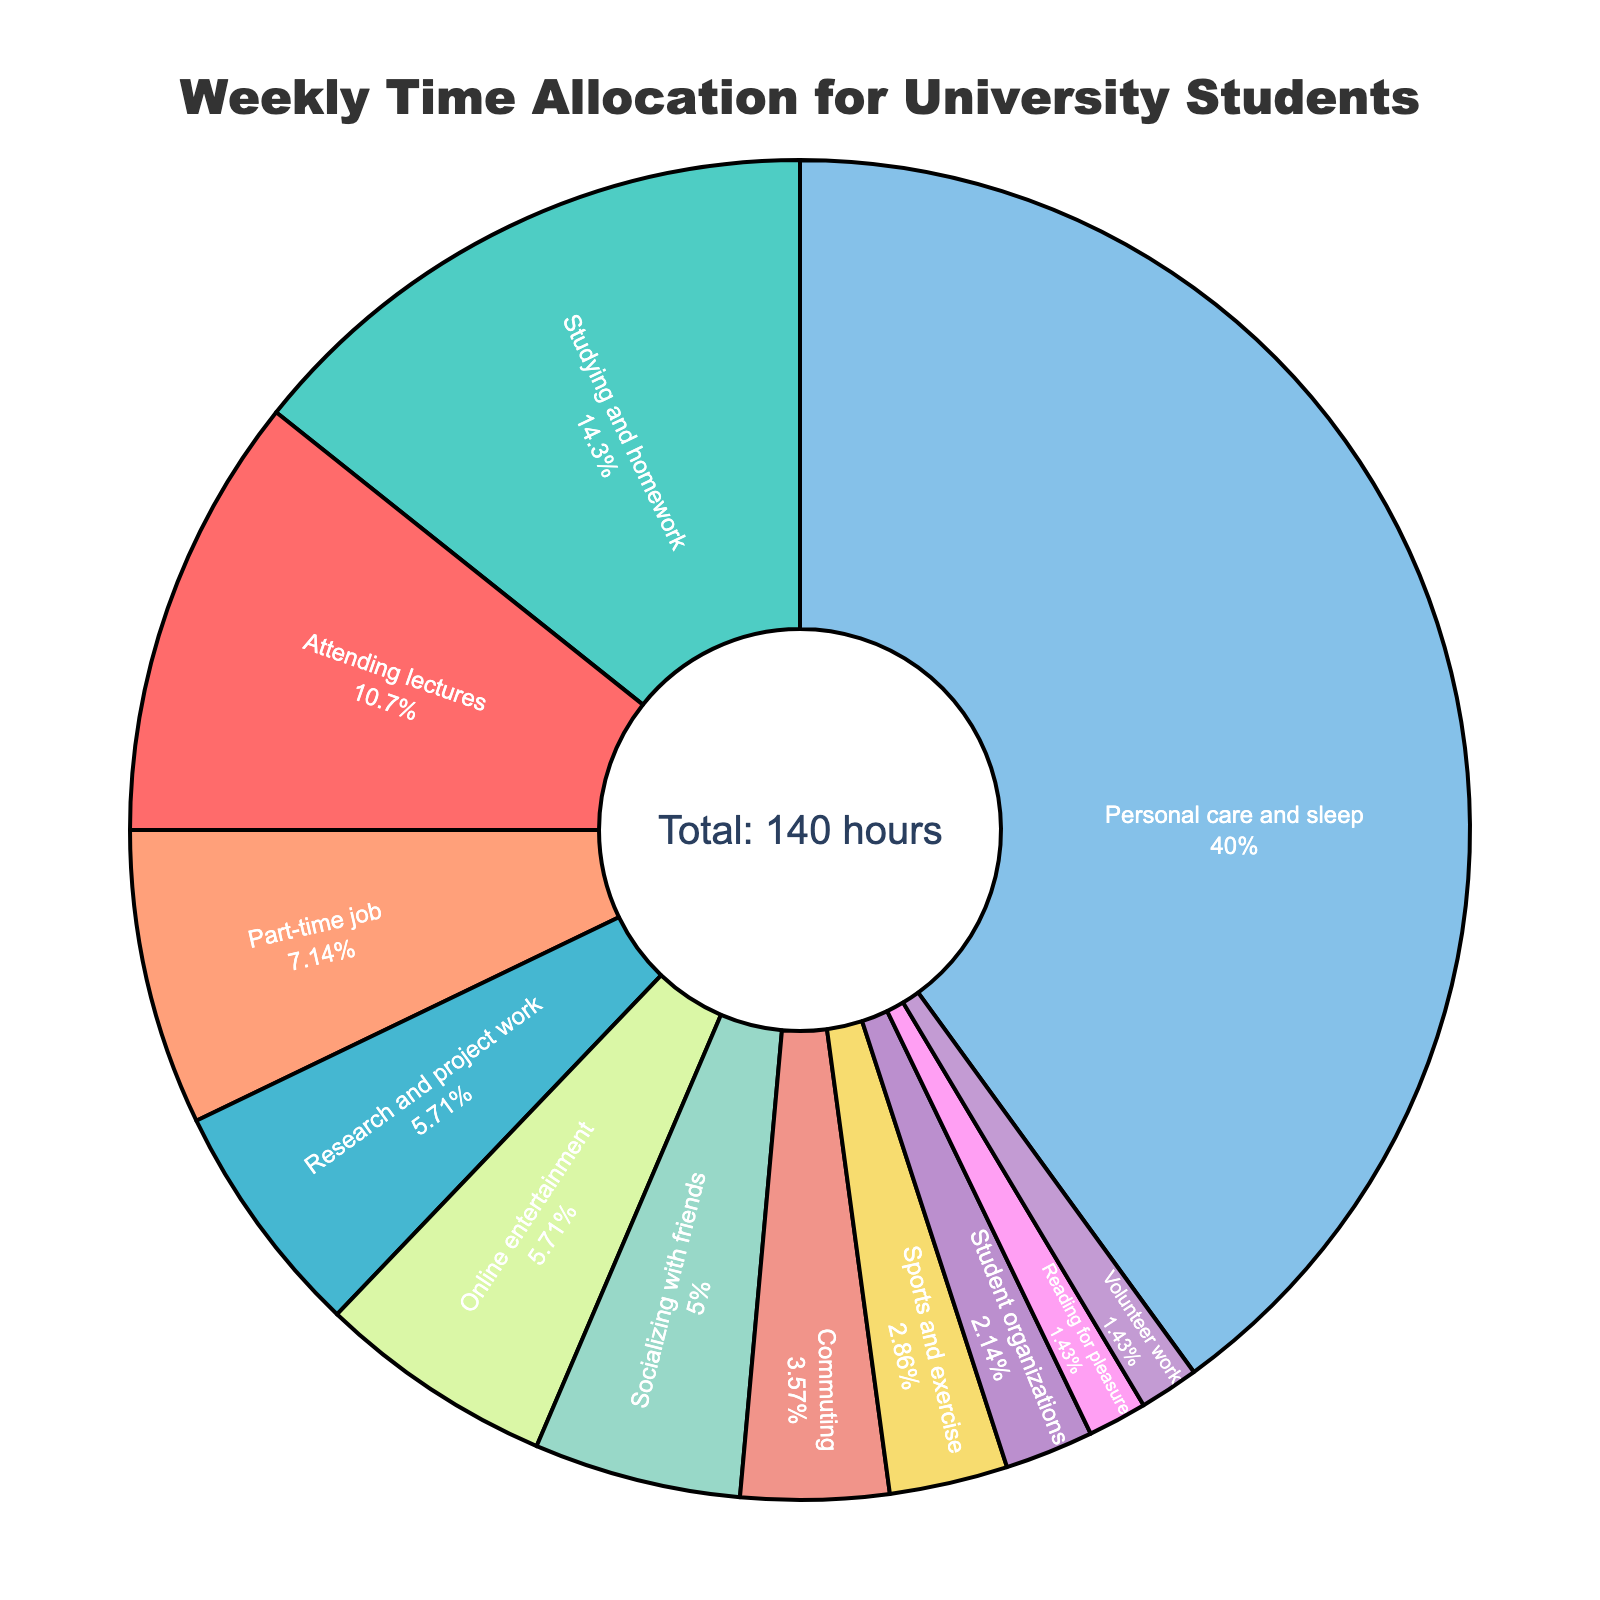what percentage of time is spent on studying and homework relative to attending lectures? To calculate the relative percentage, use the formula (Studying and homework hours / Attending lectures hours) x 100. Here, (20 / 15) x 100 = 133.33%.
Answer: 133.33% Which activity requires the most time? The figure shows that 'Personal care and sleep' occupies the largest portion of the pie chart.
Answer: Personal care and sleep How much more time is spent on a part-time job compared to student organizations? Subtract the hours for student organizations from the hours for part-time jobs: 10 - 3 = 7 hours.
Answer: 7 hours What is the total percentage of time spent on sports and exercise, reading for pleasure, and volunteer work? Sum the hours for sports and exercise (4), reading for pleasure (2), and volunteer work (2). Total hours = 4 + 2 + 2 = 8. Calculate the percentage: (8 / 140) x 100 = 5.71%.
Answer: 5.71% How does the time spent on research and project work compare to the time spent on socializing with friends? Subtract the hours for socializing with friends from the hours for research and project work: 8 - 7 = 1 hour.
Answer: 1 hour Which activity has almost the same percentage of time allocation as attending lectures? 'Online entertainment' has 8 hours, which is close in percentage to 'Attending lectures' with 15 hours. Calculate: (8 / 140) x 100 ≈ 5.71% vs. (15 / 140) x 100 ≈ 10.71%. Although not exactly the same, online entertainment is the closest in time allocation.
Answer: Online entertainment What color represents the time spent on commuting? From the visual cues in the pie chart, commuting is marked with a color that the viewer identifies (for instance, green or another specified color).
Answer: (Identify the color as shown on the chart, likely green) How many hours in total are spent on all academic activities (attending lectures, studying and homework, and research and project work)? Sum up the hours spent on these activities: 15 (lectures) + 20 (homework) + 8 (research) = 43 hours.
Answer: 43 hours If the time spent online entertainment was reduced by half, what percentage of the total time would it represent? Calculate half of the 8 hours: 8 / 2 = 4. Then, compute the new percentage: (4 / 140) x 100 = 2.86%.
Answer: 2.86% Compare the time spent on socializing with friends to the combined time spent on student organizations and volunteer work. Sum the hours for student organizations (3) and volunteer work (2): 3 + 2 = 5 hours. Since socializing with friends is 7 hours, compare: 7 hours vs 5 hours.
Answer: 2 hours more 